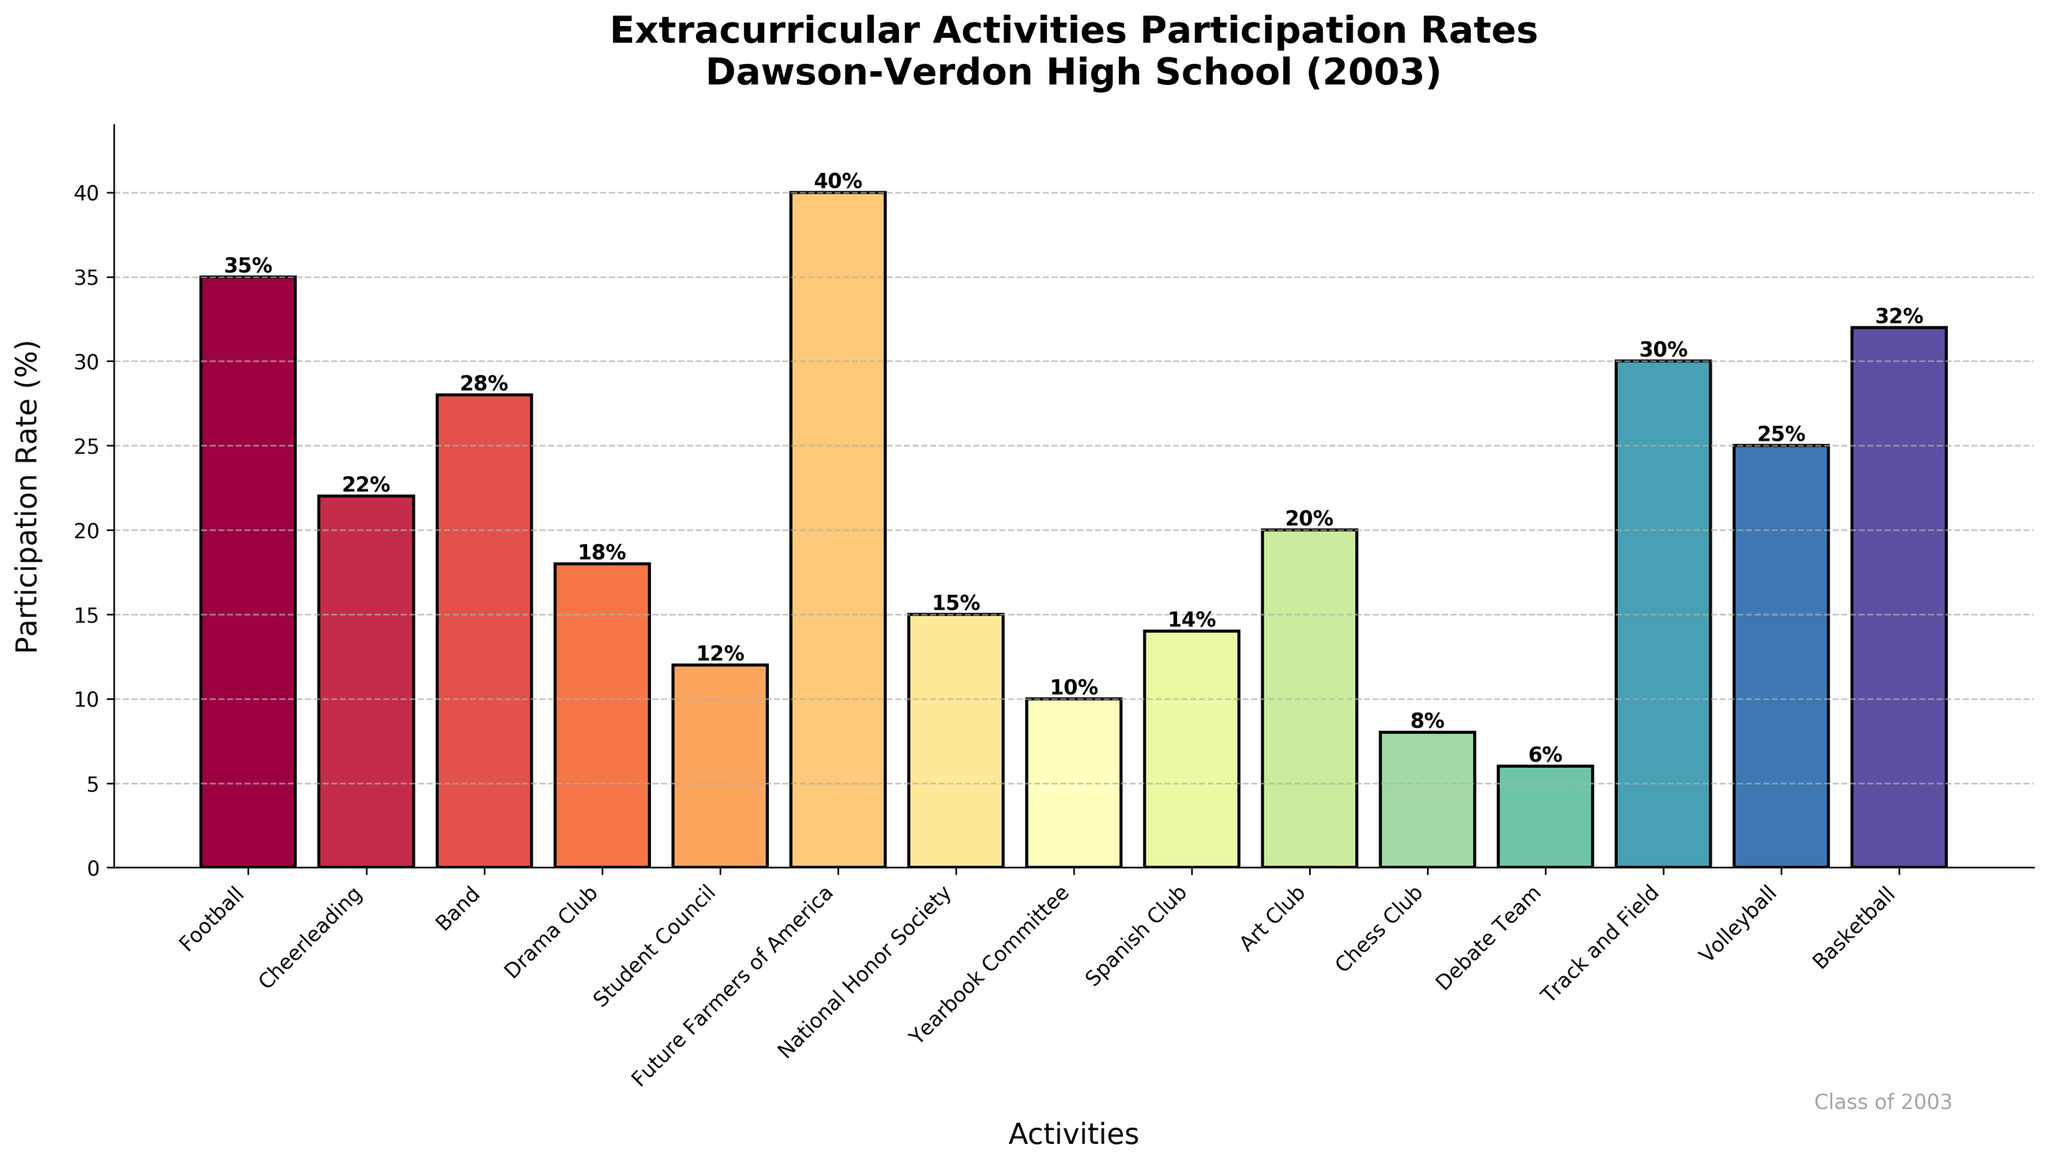Which extracurricular activity had the highest participation rate in 2003? The bar for Future Farmers of America is the tallest, reaching 40%, indicating it had the highest participation rate.
Answer: Future Farmers of America (40%) Which activity had the lowest participation rate? The bar for Debate Team is the shortest, showing a height of 6%, making it the activity with the lowest participation rate.
Answer: Debate Team (6%) How many activities had a participation rate of 20% or higher? Activities with bars reaching or exceeding the 20% mark include Football, Cheerleading, Band, Art Club, Track and Field, Basketball, Volleyball, and Future Farmers of America. Counting these activities provides the answer.
Answer: 8 What is the total participation rate for Student Council, National Honor Society, and Yearbook Committee combined? Adding the participation rates for Student Council (12%), National Honor Society (15%), and Yearbook Committee (10%) gives the total. So, 12% + 15% + 10% = 37%.
Answer: 37% Which is more popular, Band or Basketball, and by how much? The participation rate for Band is 28%, and for Basketball it is 32%. The difference can be calculated as 32% - 28% = 4%.
Answer: Basketball, by 4% Are there more activities with a participation rate above 25% or below 25%? Counting the activities with bars above 25% includes Football, Future Farmers of America, Track and Field, Volleyball, Basketball, and Band (6 activities). Those below include Cheerleading, Drama Club, Student Council, National Honor Society, Yearbook Committee, Spanish Club, Art Club, Chess Club, and Debate Team (9 activities). Thus, there are more activities below 25%.
Answer: Below 25% What is the average participation rate of all activities combined? Adding all participation rates: 35 + 22 + 28 + 18 + 12 + 40 + 15 + 10 + 14 + 20 + 8 + 6 + 30 + 25 + 32 = 315. Dividing this by the number of activities (15) gives the average: 315 / 15 = 21%.
Answer: 21% Which three activities had the closest participation rates? Observing the similar bar heights, Drama Club (18%), Art Club (20%), and Spanish Club (14%) are close. The differences are 2% between Drama Club and Art Club, and 4% between Drama Club and Spanish Club. This is less compared to others.
Answer: Drama Club, Art Club, Spanish Club (18%, 20%, 14%) What is the difference in participation rates between the most and least popular activities? Future Farmers of America have the highest participation rate at 40%, while Debate Team has the lowest at 6%. The difference is 40% - 6% = 34%.
Answer: 34% Which activity has a participation rate closest to the overall average participation rate of 21%? The overall average is 21%. The Art Club has a participation rate of 20%, which is closest to the average.
Answer: Art Club (20%) 